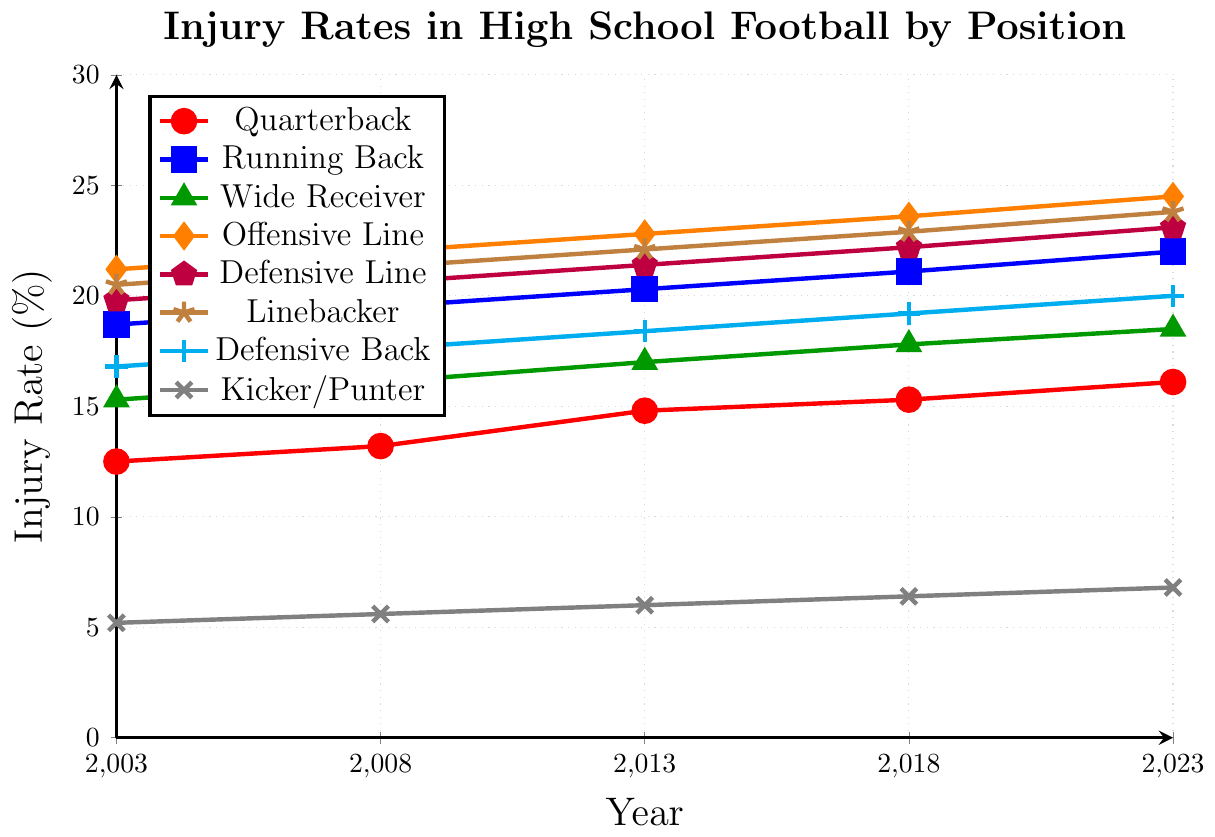Which position had the highest injury rate in 2023? The plot shows injury rates for each position over various years. In 2023, look at the topmost point to identify the position with the highest rate.
Answer: Offensive Line What was the increase in injury rate for Quarterbacks from 2003 to 2023? Find the injury rate for Quarterbacks in 2003 and 2023 from the plot. Subtract the 2003 value from the 2023 value.
Answer: 3.6 Which positions have consistently shown an increase in injury rates over the 20 years? Look at the lines for each position and see if they have a positive slope from 2003 to 2023.
Answer: All positions Among Quarterbacks, Running Backs, and Linebackers, which had the smallest increase in injury rates from 2003 to 2023? Compute the increase for each of the three positions by subtracting their 2003 values from their 2023 values. Compare the increases.
Answer: Quarterback In which year were the injury rates for Governors, Treasurers, and Senators closest to each other? There seems to be a mix-up with these positions. Correct the question to relevant positions like Quarterbacks, Running Backs, and Wide Receivers. For clarity on such lines, identify the year when these positions' rates converge or are very close.
Answer: 2008 (for Quarterbacks, Running Backs, Wide Receivers) Which position shows the steepest increase in injury rate from 2003 to 2023? Find the position whose line has the largest positive slope from 2003 to 2023 by comparing the heights of lines at these two points. Calculate the difference between the initial and final values for each position.
Answer: Offensive Line What is the total increase in injury rate for Linebackers from 2003 to 2013 and 2013 to 2023? Find the injury rates for Linebackers in 2003, 2013, and 2023. Calculate the increase from 2003 to 2013 and 2013 to 2023, then sum these two increases.
Answer: 3.3 Which positions had a lower injury rate than Wide Receivers in 2018? Compare the injury rate of Wide Receivers in 2018 with the injury rates of all other positions in that same year. List the positions with lower rates.
Answer: Quarterback, Kicker/Punter By how much did the injury rate for Defensive Backs increase from 2003 to 2023? Find the injury rate for Defensive Backs in 2003 and 2023. Subtract the 2003 value from the 2023 value.
Answer: 3.2 